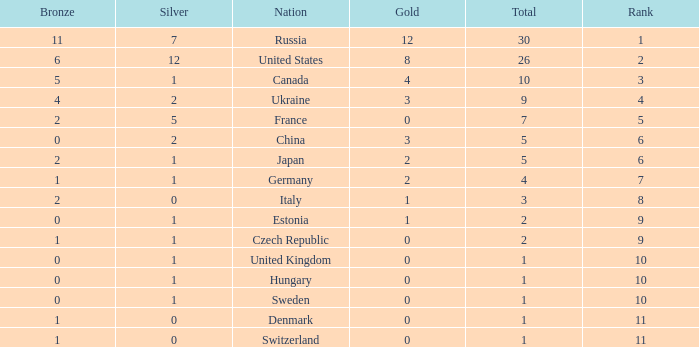Which silver has a Gold smaller than 12, a Rank smaller than 5, and a Bronze of 5? 1.0. 